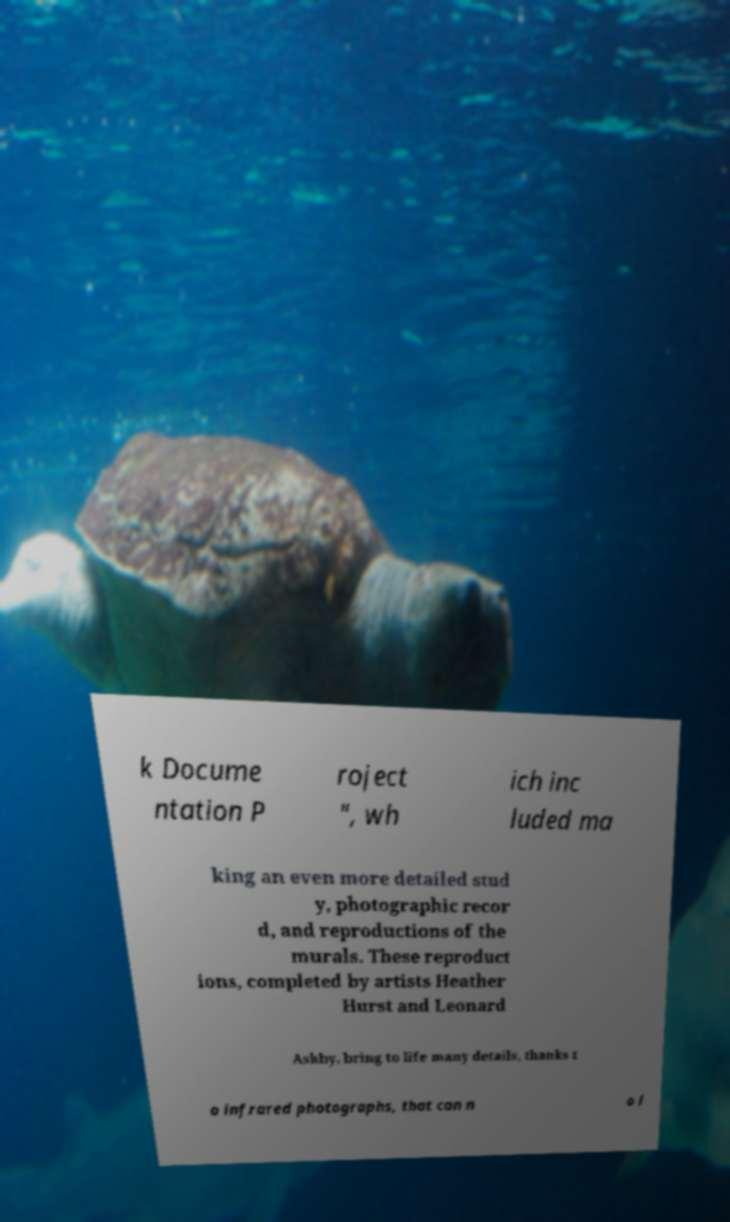Could you assist in decoding the text presented in this image and type it out clearly? k Docume ntation P roject ", wh ich inc luded ma king an even more detailed stud y, photographic recor d, and reproductions of the murals. These reproduct ions, completed by artists Heather Hurst and Leonard Ashby, bring to life many details, thanks t o infrared photographs, that can n o l 